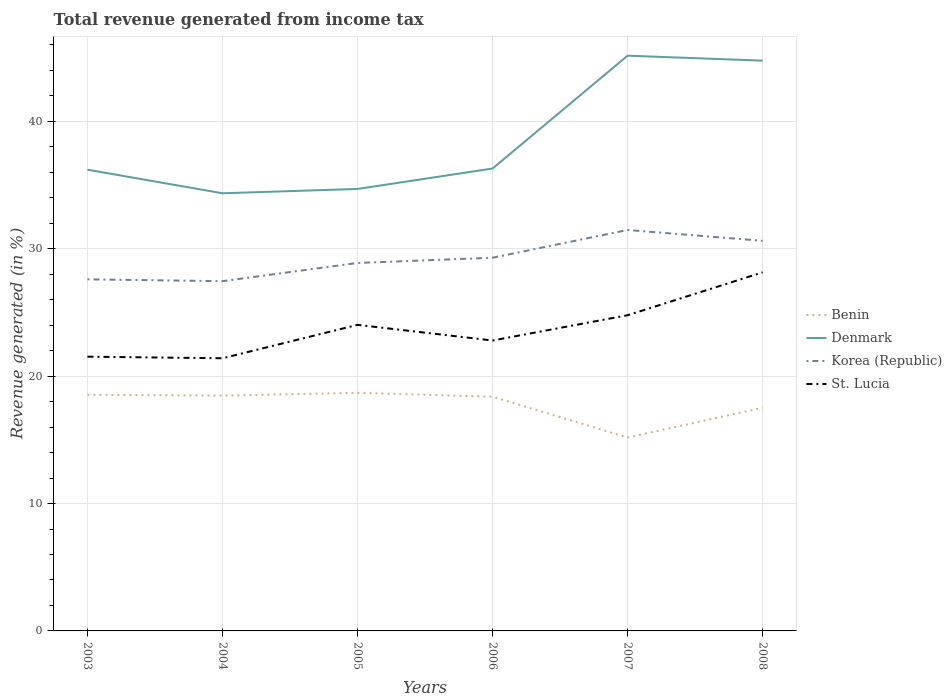How many different coloured lines are there?
Make the answer very short. 4. Does the line corresponding to Korea (Republic) intersect with the line corresponding to Denmark?
Offer a terse response. No. Across all years, what is the maximum total revenue generated in Korea (Republic)?
Keep it short and to the point. 27.45. What is the total total revenue generated in Benin in the graph?
Give a very brief answer. -2.33. What is the difference between the highest and the second highest total revenue generated in Benin?
Provide a succinct answer. 3.51. Is the total revenue generated in St. Lucia strictly greater than the total revenue generated in Denmark over the years?
Offer a very short reply. Yes. How many lines are there?
Offer a very short reply. 4. What is the difference between two consecutive major ticks on the Y-axis?
Your answer should be compact. 10. Where does the legend appear in the graph?
Provide a short and direct response. Center right. How are the legend labels stacked?
Provide a short and direct response. Vertical. What is the title of the graph?
Ensure brevity in your answer.  Total revenue generated from income tax. Does "Burkina Faso" appear as one of the legend labels in the graph?
Provide a short and direct response. No. What is the label or title of the X-axis?
Offer a very short reply. Years. What is the label or title of the Y-axis?
Keep it short and to the point. Revenue generated (in %). What is the Revenue generated (in %) of Benin in 2003?
Your answer should be very brief. 18.54. What is the Revenue generated (in %) in Denmark in 2003?
Ensure brevity in your answer.  36.2. What is the Revenue generated (in %) in Korea (Republic) in 2003?
Ensure brevity in your answer.  27.6. What is the Revenue generated (in %) in St. Lucia in 2003?
Keep it short and to the point. 21.53. What is the Revenue generated (in %) of Benin in 2004?
Offer a very short reply. 18.47. What is the Revenue generated (in %) in Denmark in 2004?
Ensure brevity in your answer.  34.35. What is the Revenue generated (in %) of Korea (Republic) in 2004?
Provide a succinct answer. 27.45. What is the Revenue generated (in %) of St. Lucia in 2004?
Keep it short and to the point. 21.4. What is the Revenue generated (in %) of Benin in 2005?
Your answer should be very brief. 18.69. What is the Revenue generated (in %) in Denmark in 2005?
Your response must be concise. 34.69. What is the Revenue generated (in %) in Korea (Republic) in 2005?
Provide a succinct answer. 28.88. What is the Revenue generated (in %) of St. Lucia in 2005?
Provide a short and direct response. 24.02. What is the Revenue generated (in %) in Benin in 2006?
Make the answer very short. 18.38. What is the Revenue generated (in %) of Denmark in 2006?
Ensure brevity in your answer.  36.29. What is the Revenue generated (in %) of Korea (Republic) in 2006?
Offer a very short reply. 29.29. What is the Revenue generated (in %) in St. Lucia in 2006?
Your answer should be very brief. 22.8. What is the Revenue generated (in %) of Benin in 2007?
Your answer should be very brief. 15.18. What is the Revenue generated (in %) of Denmark in 2007?
Offer a very short reply. 45.15. What is the Revenue generated (in %) of Korea (Republic) in 2007?
Provide a short and direct response. 31.47. What is the Revenue generated (in %) of St. Lucia in 2007?
Offer a terse response. 24.78. What is the Revenue generated (in %) of Benin in 2008?
Offer a very short reply. 17.52. What is the Revenue generated (in %) in Denmark in 2008?
Your response must be concise. 44.76. What is the Revenue generated (in %) in Korea (Republic) in 2008?
Your answer should be compact. 30.62. What is the Revenue generated (in %) in St. Lucia in 2008?
Your answer should be very brief. 28.15. Across all years, what is the maximum Revenue generated (in %) in Benin?
Provide a short and direct response. 18.69. Across all years, what is the maximum Revenue generated (in %) of Denmark?
Your response must be concise. 45.15. Across all years, what is the maximum Revenue generated (in %) of Korea (Republic)?
Your response must be concise. 31.47. Across all years, what is the maximum Revenue generated (in %) in St. Lucia?
Provide a short and direct response. 28.15. Across all years, what is the minimum Revenue generated (in %) in Benin?
Offer a terse response. 15.18. Across all years, what is the minimum Revenue generated (in %) in Denmark?
Make the answer very short. 34.35. Across all years, what is the minimum Revenue generated (in %) of Korea (Republic)?
Ensure brevity in your answer.  27.45. Across all years, what is the minimum Revenue generated (in %) in St. Lucia?
Your answer should be compact. 21.4. What is the total Revenue generated (in %) in Benin in the graph?
Offer a very short reply. 106.78. What is the total Revenue generated (in %) in Denmark in the graph?
Offer a very short reply. 231.46. What is the total Revenue generated (in %) of Korea (Republic) in the graph?
Keep it short and to the point. 175.31. What is the total Revenue generated (in %) in St. Lucia in the graph?
Offer a terse response. 142.67. What is the difference between the Revenue generated (in %) in Benin in 2003 and that in 2004?
Offer a terse response. 0.07. What is the difference between the Revenue generated (in %) of Denmark in 2003 and that in 2004?
Your response must be concise. 1.85. What is the difference between the Revenue generated (in %) of Korea (Republic) in 2003 and that in 2004?
Give a very brief answer. 0.14. What is the difference between the Revenue generated (in %) of St. Lucia in 2003 and that in 2004?
Your answer should be very brief. 0.13. What is the difference between the Revenue generated (in %) in Benin in 2003 and that in 2005?
Ensure brevity in your answer.  -0.15. What is the difference between the Revenue generated (in %) in Denmark in 2003 and that in 2005?
Offer a terse response. 1.51. What is the difference between the Revenue generated (in %) in Korea (Republic) in 2003 and that in 2005?
Your answer should be compact. -1.29. What is the difference between the Revenue generated (in %) of St. Lucia in 2003 and that in 2005?
Your answer should be very brief. -2.5. What is the difference between the Revenue generated (in %) in Benin in 2003 and that in 2006?
Keep it short and to the point. 0.16. What is the difference between the Revenue generated (in %) of Denmark in 2003 and that in 2006?
Offer a very short reply. -0.09. What is the difference between the Revenue generated (in %) of Korea (Republic) in 2003 and that in 2006?
Provide a short and direct response. -1.7. What is the difference between the Revenue generated (in %) of St. Lucia in 2003 and that in 2006?
Give a very brief answer. -1.27. What is the difference between the Revenue generated (in %) in Benin in 2003 and that in 2007?
Give a very brief answer. 3.36. What is the difference between the Revenue generated (in %) in Denmark in 2003 and that in 2007?
Provide a succinct answer. -8.95. What is the difference between the Revenue generated (in %) of Korea (Republic) in 2003 and that in 2007?
Offer a very short reply. -3.88. What is the difference between the Revenue generated (in %) of St. Lucia in 2003 and that in 2007?
Ensure brevity in your answer.  -3.25. What is the difference between the Revenue generated (in %) of Benin in 2003 and that in 2008?
Your response must be concise. 1.03. What is the difference between the Revenue generated (in %) of Denmark in 2003 and that in 2008?
Provide a short and direct response. -8.56. What is the difference between the Revenue generated (in %) in Korea (Republic) in 2003 and that in 2008?
Provide a succinct answer. -3.02. What is the difference between the Revenue generated (in %) of St. Lucia in 2003 and that in 2008?
Your answer should be very brief. -6.62. What is the difference between the Revenue generated (in %) of Benin in 2004 and that in 2005?
Offer a very short reply. -0.22. What is the difference between the Revenue generated (in %) of Denmark in 2004 and that in 2005?
Keep it short and to the point. -0.34. What is the difference between the Revenue generated (in %) of Korea (Republic) in 2004 and that in 2005?
Offer a very short reply. -1.43. What is the difference between the Revenue generated (in %) in St. Lucia in 2004 and that in 2005?
Offer a terse response. -2.62. What is the difference between the Revenue generated (in %) in Benin in 2004 and that in 2006?
Keep it short and to the point. 0.09. What is the difference between the Revenue generated (in %) of Denmark in 2004 and that in 2006?
Provide a succinct answer. -1.94. What is the difference between the Revenue generated (in %) of Korea (Republic) in 2004 and that in 2006?
Your answer should be compact. -1.84. What is the difference between the Revenue generated (in %) in St. Lucia in 2004 and that in 2006?
Provide a succinct answer. -1.39. What is the difference between the Revenue generated (in %) of Benin in 2004 and that in 2007?
Keep it short and to the point. 3.29. What is the difference between the Revenue generated (in %) in Denmark in 2004 and that in 2007?
Provide a succinct answer. -10.8. What is the difference between the Revenue generated (in %) in Korea (Republic) in 2004 and that in 2007?
Your response must be concise. -4.02. What is the difference between the Revenue generated (in %) of St. Lucia in 2004 and that in 2007?
Provide a succinct answer. -3.38. What is the difference between the Revenue generated (in %) in Benin in 2004 and that in 2008?
Provide a short and direct response. 0.95. What is the difference between the Revenue generated (in %) in Denmark in 2004 and that in 2008?
Your response must be concise. -10.41. What is the difference between the Revenue generated (in %) of Korea (Republic) in 2004 and that in 2008?
Keep it short and to the point. -3.17. What is the difference between the Revenue generated (in %) in St. Lucia in 2004 and that in 2008?
Ensure brevity in your answer.  -6.74. What is the difference between the Revenue generated (in %) in Benin in 2005 and that in 2006?
Offer a terse response. 0.31. What is the difference between the Revenue generated (in %) of Denmark in 2005 and that in 2006?
Keep it short and to the point. -1.6. What is the difference between the Revenue generated (in %) of Korea (Republic) in 2005 and that in 2006?
Your response must be concise. -0.41. What is the difference between the Revenue generated (in %) of St. Lucia in 2005 and that in 2006?
Your response must be concise. 1.23. What is the difference between the Revenue generated (in %) of Benin in 2005 and that in 2007?
Provide a succinct answer. 3.51. What is the difference between the Revenue generated (in %) of Denmark in 2005 and that in 2007?
Ensure brevity in your answer.  -10.46. What is the difference between the Revenue generated (in %) of Korea (Republic) in 2005 and that in 2007?
Your answer should be very brief. -2.59. What is the difference between the Revenue generated (in %) of St. Lucia in 2005 and that in 2007?
Your response must be concise. -0.76. What is the difference between the Revenue generated (in %) of Benin in 2005 and that in 2008?
Give a very brief answer. 1.17. What is the difference between the Revenue generated (in %) of Denmark in 2005 and that in 2008?
Ensure brevity in your answer.  -10.07. What is the difference between the Revenue generated (in %) of Korea (Republic) in 2005 and that in 2008?
Offer a terse response. -1.74. What is the difference between the Revenue generated (in %) of St. Lucia in 2005 and that in 2008?
Your response must be concise. -4.12. What is the difference between the Revenue generated (in %) of Benin in 2006 and that in 2007?
Keep it short and to the point. 3.2. What is the difference between the Revenue generated (in %) of Denmark in 2006 and that in 2007?
Your response must be concise. -8.86. What is the difference between the Revenue generated (in %) of Korea (Republic) in 2006 and that in 2007?
Your answer should be compact. -2.18. What is the difference between the Revenue generated (in %) of St. Lucia in 2006 and that in 2007?
Provide a succinct answer. -1.98. What is the difference between the Revenue generated (in %) in Benin in 2006 and that in 2008?
Ensure brevity in your answer.  0.87. What is the difference between the Revenue generated (in %) in Denmark in 2006 and that in 2008?
Your answer should be compact. -8.47. What is the difference between the Revenue generated (in %) of Korea (Republic) in 2006 and that in 2008?
Make the answer very short. -1.33. What is the difference between the Revenue generated (in %) of St. Lucia in 2006 and that in 2008?
Your answer should be compact. -5.35. What is the difference between the Revenue generated (in %) of Benin in 2007 and that in 2008?
Keep it short and to the point. -2.33. What is the difference between the Revenue generated (in %) in Denmark in 2007 and that in 2008?
Your answer should be very brief. 0.39. What is the difference between the Revenue generated (in %) in Korea (Republic) in 2007 and that in 2008?
Your answer should be very brief. 0.85. What is the difference between the Revenue generated (in %) in St. Lucia in 2007 and that in 2008?
Make the answer very short. -3.37. What is the difference between the Revenue generated (in %) of Benin in 2003 and the Revenue generated (in %) of Denmark in 2004?
Offer a terse response. -15.81. What is the difference between the Revenue generated (in %) in Benin in 2003 and the Revenue generated (in %) in Korea (Republic) in 2004?
Give a very brief answer. -8.91. What is the difference between the Revenue generated (in %) in Benin in 2003 and the Revenue generated (in %) in St. Lucia in 2004?
Keep it short and to the point. -2.86. What is the difference between the Revenue generated (in %) in Denmark in 2003 and the Revenue generated (in %) in Korea (Republic) in 2004?
Your answer should be very brief. 8.75. What is the difference between the Revenue generated (in %) in Denmark in 2003 and the Revenue generated (in %) in St. Lucia in 2004?
Keep it short and to the point. 14.8. What is the difference between the Revenue generated (in %) of Korea (Republic) in 2003 and the Revenue generated (in %) of St. Lucia in 2004?
Offer a terse response. 6.19. What is the difference between the Revenue generated (in %) in Benin in 2003 and the Revenue generated (in %) in Denmark in 2005?
Provide a short and direct response. -16.15. What is the difference between the Revenue generated (in %) in Benin in 2003 and the Revenue generated (in %) in Korea (Republic) in 2005?
Your response must be concise. -10.34. What is the difference between the Revenue generated (in %) in Benin in 2003 and the Revenue generated (in %) in St. Lucia in 2005?
Your answer should be very brief. -5.48. What is the difference between the Revenue generated (in %) in Denmark in 2003 and the Revenue generated (in %) in Korea (Republic) in 2005?
Keep it short and to the point. 7.32. What is the difference between the Revenue generated (in %) of Denmark in 2003 and the Revenue generated (in %) of St. Lucia in 2005?
Offer a terse response. 12.18. What is the difference between the Revenue generated (in %) in Korea (Republic) in 2003 and the Revenue generated (in %) in St. Lucia in 2005?
Your response must be concise. 3.57. What is the difference between the Revenue generated (in %) in Benin in 2003 and the Revenue generated (in %) in Denmark in 2006?
Provide a succinct answer. -17.75. What is the difference between the Revenue generated (in %) of Benin in 2003 and the Revenue generated (in %) of Korea (Republic) in 2006?
Make the answer very short. -10.75. What is the difference between the Revenue generated (in %) of Benin in 2003 and the Revenue generated (in %) of St. Lucia in 2006?
Give a very brief answer. -4.25. What is the difference between the Revenue generated (in %) in Denmark in 2003 and the Revenue generated (in %) in Korea (Republic) in 2006?
Your answer should be very brief. 6.91. What is the difference between the Revenue generated (in %) of Denmark in 2003 and the Revenue generated (in %) of St. Lucia in 2006?
Your response must be concise. 13.41. What is the difference between the Revenue generated (in %) of Korea (Republic) in 2003 and the Revenue generated (in %) of St. Lucia in 2006?
Ensure brevity in your answer.  4.8. What is the difference between the Revenue generated (in %) in Benin in 2003 and the Revenue generated (in %) in Denmark in 2007?
Your answer should be compact. -26.61. What is the difference between the Revenue generated (in %) of Benin in 2003 and the Revenue generated (in %) of Korea (Republic) in 2007?
Ensure brevity in your answer.  -12.93. What is the difference between the Revenue generated (in %) in Benin in 2003 and the Revenue generated (in %) in St. Lucia in 2007?
Offer a terse response. -6.24. What is the difference between the Revenue generated (in %) in Denmark in 2003 and the Revenue generated (in %) in Korea (Republic) in 2007?
Your response must be concise. 4.73. What is the difference between the Revenue generated (in %) of Denmark in 2003 and the Revenue generated (in %) of St. Lucia in 2007?
Provide a short and direct response. 11.42. What is the difference between the Revenue generated (in %) of Korea (Republic) in 2003 and the Revenue generated (in %) of St. Lucia in 2007?
Provide a succinct answer. 2.82. What is the difference between the Revenue generated (in %) in Benin in 2003 and the Revenue generated (in %) in Denmark in 2008?
Keep it short and to the point. -26.22. What is the difference between the Revenue generated (in %) of Benin in 2003 and the Revenue generated (in %) of Korea (Republic) in 2008?
Your answer should be compact. -12.08. What is the difference between the Revenue generated (in %) of Benin in 2003 and the Revenue generated (in %) of St. Lucia in 2008?
Your response must be concise. -9.6. What is the difference between the Revenue generated (in %) of Denmark in 2003 and the Revenue generated (in %) of Korea (Republic) in 2008?
Give a very brief answer. 5.58. What is the difference between the Revenue generated (in %) in Denmark in 2003 and the Revenue generated (in %) in St. Lucia in 2008?
Provide a short and direct response. 8.06. What is the difference between the Revenue generated (in %) of Korea (Republic) in 2003 and the Revenue generated (in %) of St. Lucia in 2008?
Make the answer very short. -0.55. What is the difference between the Revenue generated (in %) in Benin in 2004 and the Revenue generated (in %) in Denmark in 2005?
Provide a succinct answer. -16.22. What is the difference between the Revenue generated (in %) of Benin in 2004 and the Revenue generated (in %) of Korea (Republic) in 2005?
Provide a succinct answer. -10.41. What is the difference between the Revenue generated (in %) in Benin in 2004 and the Revenue generated (in %) in St. Lucia in 2005?
Your response must be concise. -5.55. What is the difference between the Revenue generated (in %) in Denmark in 2004 and the Revenue generated (in %) in Korea (Republic) in 2005?
Offer a very short reply. 5.47. What is the difference between the Revenue generated (in %) of Denmark in 2004 and the Revenue generated (in %) of St. Lucia in 2005?
Your answer should be very brief. 10.33. What is the difference between the Revenue generated (in %) in Korea (Republic) in 2004 and the Revenue generated (in %) in St. Lucia in 2005?
Your answer should be compact. 3.43. What is the difference between the Revenue generated (in %) in Benin in 2004 and the Revenue generated (in %) in Denmark in 2006?
Make the answer very short. -17.82. What is the difference between the Revenue generated (in %) in Benin in 2004 and the Revenue generated (in %) in Korea (Republic) in 2006?
Give a very brief answer. -10.82. What is the difference between the Revenue generated (in %) in Benin in 2004 and the Revenue generated (in %) in St. Lucia in 2006?
Make the answer very short. -4.33. What is the difference between the Revenue generated (in %) of Denmark in 2004 and the Revenue generated (in %) of Korea (Republic) in 2006?
Make the answer very short. 5.06. What is the difference between the Revenue generated (in %) in Denmark in 2004 and the Revenue generated (in %) in St. Lucia in 2006?
Your answer should be very brief. 11.56. What is the difference between the Revenue generated (in %) of Korea (Republic) in 2004 and the Revenue generated (in %) of St. Lucia in 2006?
Give a very brief answer. 4.66. What is the difference between the Revenue generated (in %) of Benin in 2004 and the Revenue generated (in %) of Denmark in 2007?
Your answer should be very brief. -26.68. What is the difference between the Revenue generated (in %) in Benin in 2004 and the Revenue generated (in %) in Korea (Republic) in 2007?
Provide a short and direct response. -13. What is the difference between the Revenue generated (in %) of Benin in 2004 and the Revenue generated (in %) of St. Lucia in 2007?
Give a very brief answer. -6.31. What is the difference between the Revenue generated (in %) of Denmark in 2004 and the Revenue generated (in %) of Korea (Republic) in 2007?
Offer a very short reply. 2.88. What is the difference between the Revenue generated (in %) in Denmark in 2004 and the Revenue generated (in %) in St. Lucia in 2007?
Your answer should be very brief. 9.57. What is the difference between the Revenue generated (in %) in Korea (Republic) in 2004 and the Revenue generated (in %) in St. Lucia in 2007?
Give a very brief answer. 2.67. What is the difference between the Revenue generated (in %) of Benin in 2004 and the Revenue generated (in %) of Denmark in 2008?
Your response must be concise. -26.29. What is the difference between the Revenue generated (in %) in Benin in 2004 and the Revenue generated (in %) in Korea (Republic) in 2008?
Your answer should be very brief. -12.15. What is the difference between the Revenue generated (in %) of Benin in 2004 and the Revenue generated (in %) of St. Lucia in 2008?
Your response must be concise. -9.68. What is the difference between the Revenue generated (in %) of Denmark in 2004 and the Revenue generated (in %) of Korea (Republic) in 2008?
Provide a short and direct response. 3.73. What is the difference between the Revenue generated (in %) in Denmark in 2004 and the Revenue generated (in %) in St. Lucia in 2008?
Your answer should be compact. 6.21. What is the difference between the Revenue generated (in %) in Korea (Republic) in 2004 and the Revenue generated (in %) in St. Lucia in 2008?
Make the answer very short. -0.69. What is the difference between the Revenue generated (in %) in Benin in 2005 and the Revenue generated (in %) in Denmark in 2006?
Provide a short and direct response. -17.6. What is the difference between the Revenue generated (in %) in Benin in 2005 and the Revenue generated (in %) in Korea (Republic) in 2006?
Provide a succinct answer. -10.6. What is the difference between the Revenue generated (in %) of Benin in 2005 and the Revenue generated (in %) of St. Lucia in 2006?
Your response must be concise. -4.11. What is the difference between the Revenue generated (in %) of Denmark in 2005 and the Revenue generated (in %) of Korea (Republic) in 2006?
Offer a terse response. 5.4. What is the difference between the Revenue generated (in %) of Denmark in 2005 and the Revenue generated (in %) of St. Lucia in 2006?
Offer a terse response. 11.9. What is the difference between the Revenue generated (in %) in Korea (Republic) in 2005 and the Revenue generated (in %) in St. Lucia in 2006?
Offer a very short reply. 6.09. What is the difference between the Revenue generated (in %) in Benin in 2005 and the Revenue generated (in %) in Denmark in 2007?
Provide a succinct answer. -26.46. What is the difference between the Revenue generated (in %) in Benin in 2005 and the Revenue generated (in %) in Korea (Republic) in 2007?
Give a very brief answer. -12.78. What is the difference between the Revenue generated (in %) in Benin in 2005 and the Revenue generated (in %) in St. Lucia in 2007?
Keep it short and to the point. -6.09. What is the difference between the Revenue generated (in %) in Denmark in 2005 and the Revenue generated (in %) in Korea (Republic) in 2007?
Your answer should be very brief. 3.22. What is the difference between the Revenue generated (in %) in Denmark in 2005 and the Revenue generated (in %) in St. Lucia in 2007?
Provide a succinct answer. 9.91. What is the difference between the Revenue generated (in %) of Korea (Republic) in 2005 and the Revenue generated (in %) of St. Lucia in 2007?
Your answer should be compact. 4.1. What is the difference between the Revenue generated (in %) of Benin in 2005 and the Revenue generated (in %) of Denmark in 2008?
Make the answer very short. -26.07. What is the difference between the Revenue generated (in %) of Benin in 2005 and the Revenue generated (in %) of Korea (Republic) in 2008?
Provide a succinct answer. -11.93. What is the difference between the Revenue generated (in %) of Benin in 2005 and the Revenue generated (in %) of St. Lucia in 2008?
Your answer should be very brief. -9.46. What is the difference between the Revenue generated (in %) in Denmark in 2005 and the Revenue generated (in %) in Korea (Republic) in 2008?
Offer a very short reply. 4.07. What is the difference between the Revenue generated (in %) in Denmark in 2005 and the Revenue generated (in %) in St. Lucia in 2008?
Provide a succinct answer. 6.55. What is the difference between the Revenue generated (in %) of Korea (Republic) in 2005 and the Revenue generated (in %) of St. Lucia in 2008?
Your answer should be compact. 0.74. What is the difference between the Revenue generated (in %) in Benin in 2006 and the Revenue generated (in %) in Denmark in 2007?
Provide a short and direct response. -26.77. What is the difference between the Revenue generated (in %) in Benin in 2006 and the Revenue generated (in %) in Korea (Republic) in 2007?
Your response must be concise. -13.09. What is the difference between the Revenue generated (in %) of Benin in 2006 and the Revenue generated (in %) of St. Lucia in 2007?
Ensure brevity in your answer.  -6.4. What is the difference between the Revenue generated (in %) in Denmark in 2006 and the Revenue generated (in %) in Korea (Republic) in 2007?
Ensure brevity in your answer.  4.82. What is the difference between the Revenue generated (in %) in Denmark in 2006 and the Revenue generated (in %) in St. Lucia in 2007?
Your answer should be very brief. 11.52. What is the difference between the Revenue generated (in %) of Korea (Republic) in 2006 and the Revenue generated (in %) of St. Lucia in 2007?
Your answer should be compact. 4.51. What is the difference between the Revenue generated (in %) of Benin in 2006 and the Revenue generated (in %) of Denmark in 2008?
Make the answer very short. -26.38. What is the difference between the Revenue generated (in %) in Benin in 2006 and the Revenue generated (in %) in Korea (Republic) in 2008?
Ensure brevity in your answer.  -12.24. What is the difference between the Revenue generated (in %) of Benin in 2006 and the Revenue generated (in %) of St. Lucia in 2008?
Your answer should be compact. -9.76. What is the difference between the Revenue generated (in %) in Denmark in 2006 and the Revenue generated (in %) in Korea (Republic) in 2008?
Provide a succinct answer. 5.68. What is the difference between the Revenue generated (in %) in Denmark in 2006 and the Revenue generated (in %) in St. Lucia in 2008?
Your answer should be compact. 8.15. What is the difference between the Revenue generated (in %) in Korea (Republic) in 2006 and the Revenue generated (in %) in St. Lucia in 2008?
Make the answer very short. 1.15. What is the difference between the Revenue generated (in %) in Benin in 2007 and the Revenue generated (in %) in Denmark in 2008?
Offer a terse response. -29.58. What is the difference between the Revenue generated (in %) of Benin in 2007 and the Revenue generated (in %) of Korea (Republic) in 2008?
Provide a succinct answer. -15.44. What is the difference between the Revenue generated (in %) of Benin in 2007 and the Revenue generated (in %) of St. Lucia in 2008?
Your answer should be compact. -12.96. What is the difference between the Revenue generated (in %) of Denmark in 2007 and the Revenue generated (in %) of Korea (Republic) in 2008?
Ensure brevity in your answer.  14.53. What is the difference between the Revenue generated (in %) of Denmark in 2007 and the Revenue generated (in %) of St. Lucia in 2008?
Your answer should be compact. 17.01. What is the difference between the Revenue generated (in %) in Korea (Republic) in 2007 and the Revenue generated (in %) in St. Lucia in 2008?
Ensure brevity in your answer.  3.33. What is the average Revenue generated (in %) in Benin per year?
Keep it short and to the point. 17.8. What is the average Revenue generated (in %) in Denmark per year?
Give a very brief answer. 38.58. What is the average Revenue generated (in %) in Korea (Republic) per year?
Ensure brevity in your answer.  29.22. What is the average Revenue generated (in %) in St. Lucia per year?
Provide a succinct answer. 23.78. In the year 2003, what is the difference between the Revenue generated (in %) in Benin and Revenue generated (in %) in Denmark?
Offer a very short reply. -17.66. In the year 2003, what is the difference between the Revenue generated (in %) of Benin and Revenue generated (in %) of Korea (Republic)?
Provide a short and direct response. -9.05. In the year 2003, what is the difference between the Revenue generated (in %) in Benin and Revenue generated (in %) in St. Lucia?
Your answer should be very brief. -2.99. In the year 2003, what is the difference between the Revenue generated (in %) of Denmark and Revenue generated (in %) of Korea (Republic)?
Your response must be concise. 8.61. In the year 2003, what is the difference between the Revenue generated (in %) of Denmark and Revenue generated (in %) of St. Lucia?
Keep it short and to the point. 14.68. In the year 2003, what is the difference between the Revenue generated (in %) of Korea (Republic) and Revenue generated (in %) of St. Lucia?
Give a very brief answer. 6.07. In the year 2004, what is the difference between the Revenue generated (in %) of Benin and Revenue generated (in %) of Denmark?
Keep it short and to the point. -15.88. In the year 2004, what is the difference between the Revenue generated (in %) of Benin and Revenue generated (in %) of Korea (Republic)?
Make the answer very short. -8.98. In the year 2004, what is the difference between the Revenue generated (in %) of Benin and Revenue generated (in %) of St. Lucia?
Offer a very short reply. -2.93. In the year 2004, what is the difference between the Revenue generated (in %) of Denmark and Revenue generated (in %) of Korea (Republic)?
Give a very brief answer. 6.9. In the year 2004, what is the difference between the Revenue generated (in %) of Denmark and Revenue generated (in %) of St. Lucia?
Offer a very short reply. 12.95. In the year 2004, what is the difference between the Revenue generated (in %) in Korea (Republic) and Revenue generated (in %) in St. Lucia?
Your response must be concise. 6.05. In the year 2005, what is the difference between the Revenue generated (in %) of Benin and Revenue generated (in %) of Denmark?
Provide a short and direct response. -16. In the year 2005, what is the difference between the Revenue generated (in %) in Benin and Revenue generated (in %) in Korea (Republic)?
Your answer should be very brief. -10.19. In the year 2005, what is the difference between the Revenue generated (in %) of Benin and Revenue generated (in %) of St. Lucia?
Your answer should be compact. -5.33. In the year 2005, what is the difference between the Revenue generated (in %) in Denmark and Revenue generated (in %) in Korea (Republic)?
Your response must be concise. 5.81. In the year 2005, what is the difference between the Revenue generated (in %) in Denmark and Revenue generated (in %) in St. Lucia?
Keep it short and to the point. 10.67. In the year 2005, what is the difference between the Revenue generated (in %) of Korea (Republic) and Revenue generated (in %) of St. Lucia?
Provide a succinct answer. 4.86. In the year 2006, what is the difference between the Revenue generated (in %) in Benin and Revenue generated (in %) in Denmark?
Provide a succinct answer. -17.91. In the year 2006, what is the difference between the Revenue generated (in %) in Benin and Revenue generated (in %) in Korea (Republic)?
Provide a short and direct response. -10.91. In the year 2006, what is the difference between the Revenue generated (in %) of Benin and Revenue generated (in %) of St. Lucia?
Make the answer very short. -4.41. In the year 2006, what is the difference between the Revenue generated (in %) of Denmark and Revenue generated (in %) of Korea (Republic)?
Offer a very short reply. 7. In the year 2006, what is the difference between the Revenue generated (in %) of Denmark and Revenue generated (in %) of St. Lucia?
Keep it short and to the point. 13.5. In the year 2006, what is the difference between the Revenue generated (in %) in Korea (Republic) and Revenue generated (in %) in St. Lucia?
Ensure brevity in your answer.  6.5. In the year 2007, what is the difference between the Revenue generated (in %) of Benin and Revenue generated (in %) of Denmark?
Make the answer very short. -29.97. In the year 2007, what is the difference between the Revenue generated (in %) in Benin and Revenue generated (in %) in Korea (Republic)?
Provide a succinct answer. -16.29. In the year 2007, what is the difference between the Revenue generated (in %) in Benin and Revenue generated (in %) in St. Lucia?
Provide a succinct answer. -9.6. In the year 2007, what is the difference between the Revenue generated (in %) in Denmark and Revenue generated (in %) in Korea (Republic)?
Give a very brief answer. 13.68. In the year 2007, what is the difference between the Revenue generated (in %) in Denmark and Revenue generated (in %) in St. Lucia?
Your answer should be compact. 20.37. In the year 2007, what is the difference between the Revenue generated (in %) of Korea (Republic) and Revenue generated (in %) of St. Lucia?
Offer a terse response. 6.69. In the year 2008, what is the difference between the Revenue generated (in %) of Benin and Revenue generated (in %) of Denmark?
Provide a succinct answer. -27.25. In the year 2008, what is the difference between the Revenue generated (in %) of Benin and Revenue generated (in %) of Korea (Republic)?
Your answer should be very brief. -13.1. In the year 2008, what is the difference between the Revenue generated (in %) of Benin and Revenue generated (in %) of St. Lucia?
Your answer should be compact. -10.63. In the year 2008, what is the difference between the Revenue generated (in %) in Denmark and Revenue generated (in %) in Korea (Republic)?
Give a very brief answer. 14.14. In the year 2008, what is the difference between the Revenue generated (in %) in Denmark and Revenue generated (in %) in St. Lucia?
Offer a terse response. 16.62. In the year 2008, what is the difference between the Revenue generated (in %) in Korea (Republic) and Revenue generated (in %) in St. Lucia?
Make the answer very short. 2.47. What is the ratio of the Revenue generated (in %) in Benin in 2003 to that in 2004?
Keep it short and to the point. 1. What is the ratio of the Revenue generated (in %) of Denmark in 2003 to that in 2004?
Offer a terse response. 1.05. What is the ratio of the Revenue generated (in %) in St. Lucia in 2003 to that in 2004?
Make the answer very short. 1.01. What is the ratio of the Revenue generated (in %) of Denmark in 2003 to that in 2005?
Provide a succinct answer. 1.04. What is the ratio of the Revenue generated (in %) in Korea (Republic) in 2003 to that in 2005?
Provide a succinct answer. 0.96. What is the ratio of the Revenue generated (in %) in St. Lucia in 2003 to that in 2005?
Give a very brief answer. 0.9. What is the ratio of the Revenue generated (in %) in Benin in 2003 to that in 2006?
Give a very brief answer. 1.01. What is the ratio of the Revenue generated (in %) of Denmark in 2003 to that in 2006?
Provide a succinct answer. 1. What is the ratio of the Revenue generated (in %) of Korea (Republic) in 2003 to that in 2006?
Your answer should be very brief. 0.94. What is the ratio of the Revenue generated (in %) in St. Lucia in 2003 to that in 2006?
Ensure brevity in your answer.  0.94. What is the ratio of the Revenue generated (in %) in Benin in 2003 to that in 2007?
Give a very brief answer. 1.22. What is the ratio of the Revenue generated (in %) of Denmark in 2003 to that in 2007?
Give a very brief answer. 0.8. What is the ratio of the Revenue generated (in %) of Korea (Republic) in 2003 to that in 2007?
Make the answer very short. 0.88. What is the ratio of the Revenue generated (in %) in St. Lucia in 2003 to that in 2007?
Your answer should be very brief. 0.87. What is the ratio of the Revenue generated (in %) in Benin in 2003 to that in 2008?
Your answer should be compact. 1.06. What is the ratio of the Revenue generated (in %) of Denmark in 2003 to that in 2008?
Your response must be concise. 0.81. What is the ratio of the Revenue generated (in %) of Korea (Republic) in 2003 to that in 2008?
Give a very brief answer. 0.9. What is the ratio of the Revenue generated (in %) of St. Lucia in 2003 to that in 2008?
Provide a succinct answer. 0.76. What is the ratio of the Revenue generated (in %) in Denmark in 2004 to that in 2005?
Make the answer very short. 0.99. What is the ratio of the Revenue generated (in %) in Korea (Republic) in 2004 to that in 2005?
Offer a terse response. 0.95. What is the ratio of the Revenue generated (in %) in St. Lucia in 2004 to that in 2005?
Provide a succinct answer. 0.89. What is the ratio of the Revenue generated (in %) of Denmark in 2004 to that in 2006?
Your answer should be very brief. 0.95. What is the ratio of the Revenue generated (in %) in Korea (Republic) in 2004 to that in 2006?
Your answer should be compact. 0.94. What is the ratio of the Revenue generated (in %) of St. Lucia in 2004 to that in 2006?
Offer a terse response. 0.94. What is the ratio of the Revenue generated (in %) in Benin in 2004 to that in 2007?
Your answer should be very brief. 1.22. What is the ratio of the Revenue generated (in %) of Denmark in 2004 to that in 2007?
Give a very brief answer. 0.76. What is the ratio of the Revenue generated (in %) of Korea (Republic) in 2004 to that in 2007?
Your answer should be very brief. 0.87. What is the ratio of the Revenue generated (in %) of St. Lucia in 2004 to that in 2007?
Your answer should be compact. 0.86. What is the ratio of the Revenue generated (in %) in Benin in 2004 to that in 2008?
Your answer should be compact. 1.05. What is the ratio of the Revenue generated (in %) in Denmark in 2004 to that in 2008?
Your answer should be compact. 0.77. What is the ratio of the Revenue generated (in %) in Korea (Republic) in 2004 to that in 2008?
Provide a succinct answer. 0.9. What is the ratio of the Revenue generated (in %) of St. Lucia in 2004 to that in 2008?
Provide a succinct answer. 0.76. What is the ratio of the Revenue generated (in %) of Benin in 2005 to that in 2006?
Your answer should be very brief. 1.02. What is the ratio of the Revenue generated (in %) of Denmark in 2005 to that in 2006?
Your response must be concise. 0.96. What is the ratio of the Revenue generated (in %) in Korea (Republic) in 2005 to that in 2006?
Your response must be concise. 0.99. What is the ratio of the Revenue generated (in %) of St. Lucia in 2005 to that in 2006?
Keep it short and to the point. 1.05. What is the ratio of the Revenue generated (in %) in Benin in 2005 to that in 2007?
Offer a terse response. 1.23. What is the ratio of the Revenue generated (in %) of Denmark in 2005 to that in 2007?
Provide a short and direct response. 0.77. What is the ratio of the Revenue generated (in %) in Korea (Republic) in 2005 to that in 2007?
Provide a succinct answer. 0.92. What is the ratio of the Revenue generated (in %) of St. Lucia in 2005 to that in 2007?
Your answer should be compact. 0.97. What is the ratio of the Revenue generated (in %) in Benin in 2005 to that in 2008?
Ensure brevity in your answer.  1.07. What is the ratio of the Revenue generated (in %) of Denmark in 2005 to that in 2008?
Make the answer very short. 0.78. What is the ratio of the Revenue generated (in %) of Korea (Republic) in 2005 to that in 2008?
Provide a succinct answer. 0.94. What is the ratio of the Revenue generated (in %) of St. Lucia in 2005 to that in 2008?
Offer a terse response. 0.85. What is the ratio of the Revenue generated (in %) in Benin in 2006 to that in 2007?
Provide a succinct answer. 1.21. What is the ratio of the Revenue generated (in %) in Denmark in 2006 to that in 2007?
Your answer should be compact. 0.8. What is the ratio of the Revenue generated (in %) in Korea (Republic) in 2006 to that in 2007?
Your response must be concise. 0.93. What is the ratio of the Revenue generated (in %) in St. Lucia in 2006 to that in 2007?
Ensure brevity in your answer.  0.92. What is the ratio of the Revenue generated (in %) in Benin in 2006 to that in 2008?
Your answer should be compact. 1.05. What is the ratio of the Revenue generated (in %) in Denmark in 2006 to that in 2008?
Ensure brevity in your answer.  0.81. What is the ratio of the Revenue generated (in %) of Korea (Republic) in 2006 to that in 2008?
Ensure brevity in your answer.  0.96. What is the ratio of the Revenue generated (in %) of St. Lucia in 2006 to that in 2008?
Your response must be concise. 0.81. What is the ratio of the Revenue generated (in %) in Benin in 2007 to that in 2008?
Make the answer very short. 0.87. What is the ratio of the Revenue generated (in %) of Denmark in 2007 to that in 2008?
Provide a succinct answer. 1.01. What is the ratio of the Revenue generated (in %) in Korea (Republic) in 2007 to that in 2008?
Your response must be concise. 1.03. What is the ratio of the Revenue generated (in %) in St. Lucia in 2007 to that in 2008?
Ensure brevity in your answer.  0.88. What is the difference between the highest and the second highest Revenue generated (in %) of Benin?
Your answer should be compact. 0.15. What is the difference between the highest and the second highest Revenue generated (in %) in Denmark?
Make the answer very short. 0.39. What is the difference between the highest and the second highest Revenue generated (in %) of Korea (Republic)?
Offer a very short reply. 0.85. What is the difference between the highest and the second highest Revenue generated (in %) of St. Lucia?
Provide a short and direct response. 3.37. What is the difference between the highest and the lowest Revenue generated (in %) of Benin?
Offer a very short reply. 3.51. What is the difference between the highest and the lowest Revenue generated (in %) in Denmark?
Give a very brief answer. 10.8. What is the difference between the highest and the lowest Revenue generated (in %) in Korea (Republic)?
Offer a terse response. 4.02. What is the difference between the highest and the lowest Revenue generated (in %) of St. Lucia?
Keep it short and to the point. 6.74. 